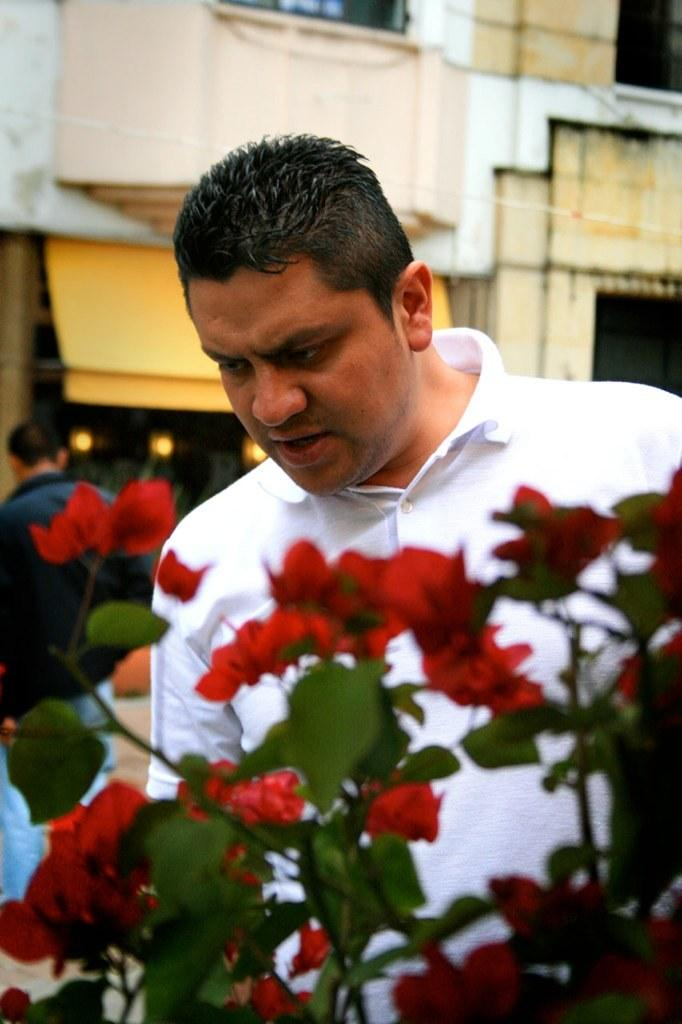How many people are in the image? There are two people standing in the image. What is in front of the man? There are flowers in front of the man. Are the flowers part of a plant? Yes, the flowers are associated with a plant. What can be seen behind the people? There is a building behind the people. What is visible in the background of the image? Lights are present in the background of the image. What type of laborer is working on the mailbox in the image? There is no laborer or mailbox present in the image. 